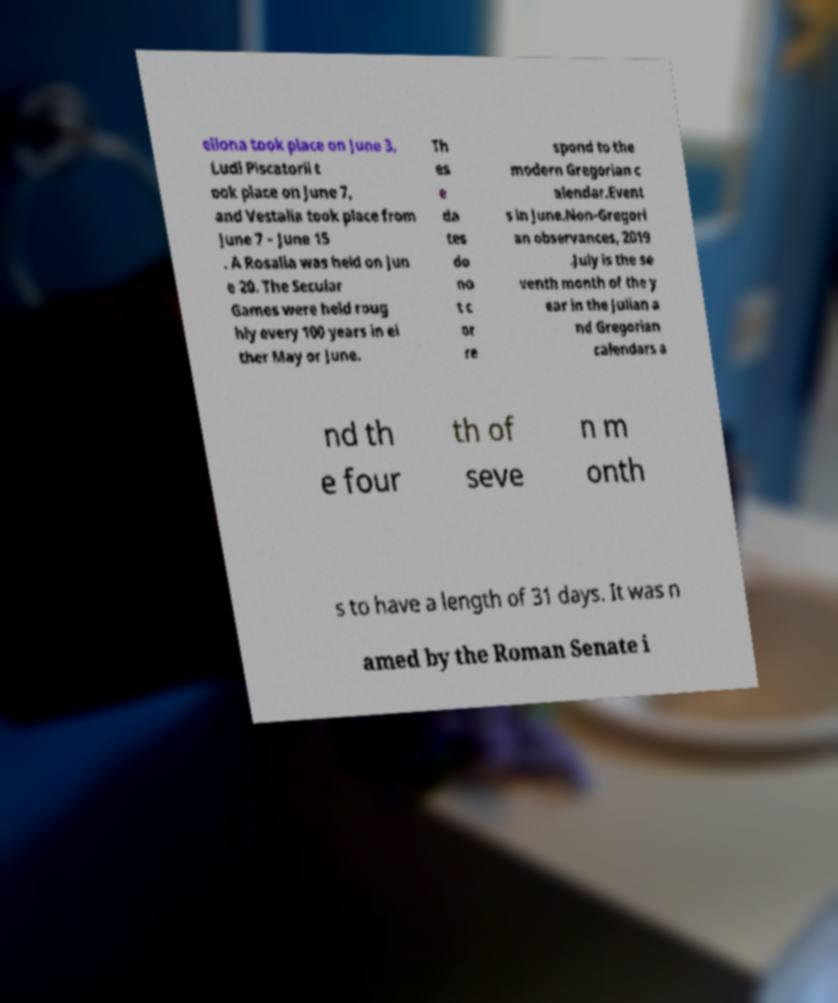For documentation purposes, I need the text within this image transcribed. Could you provide that? ellona took place on June 3, Ludi Piscatorii t ook place on June 7, and Vestalia took place from June 7 – June 15 . A Rosalia was held on Jun e 20. The Secular Games were held roug hly every 100 years in ei ther May or June. Th es e da tes do no t c or re spond to the modern Gregorian c alendar.Event s in June.Non-Gregori an observances, 2019 .July is the se venth month of the y ear in the Julian a nd Gregorian calendars a nd th e four th of seve n m onth s to have a length of 31 days. It was n amed by the Roman Senate i 